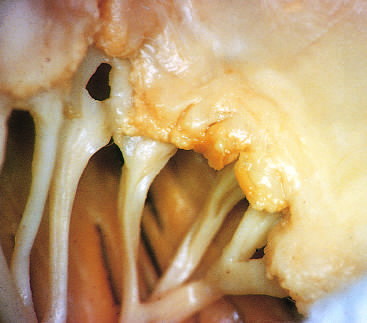what is superimposed on chronic rheumatic heart disease?
Answer the question using a single word or phrase. Acute rheumatic mitral valvulitis 